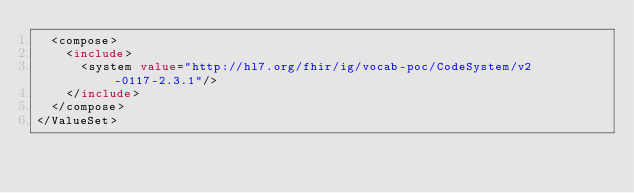<code> <loc_0><loc_0><loc_500><loc_500><_XML_>  <compose>
    <include>
      <system value="http://hl7.org/fhir/ig/vocab-poc/CodeSystem/v2-0117-2.3.1"/>
    </include>
  </compose>
</ValueSet></code> 